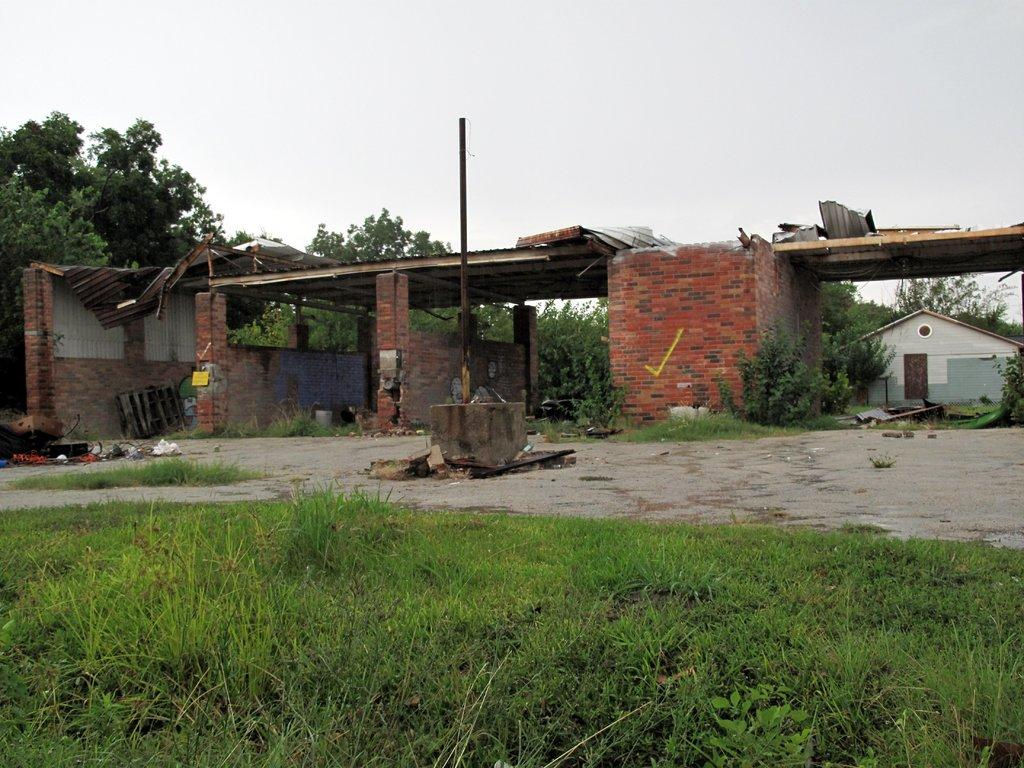What type of landscape is visible in the foreground of the image? There is a grassland in the foreground of the image. What structure can be seen in the image? There is a pole in the image. What type of buildings are present in the image? There are sheds in the image. What other items can be seen in the image? There are other items in the image, including metal sheets. What type of vegetation is visible in the image? There are trees in the image. What type of dwelling is present in the image? There is a house in the image. What can be seen in the background of the image? The sky is visible in the background of the image. What type of government is depicted in the image? There is no depiction of a government in the image; it features a grassland, pole, sheds, metal sheets, trees, house, and sky. What behavior is exhibited by the trees in the image? The trees in the image are not exhibiting any behavior, as they are stationary plants. 